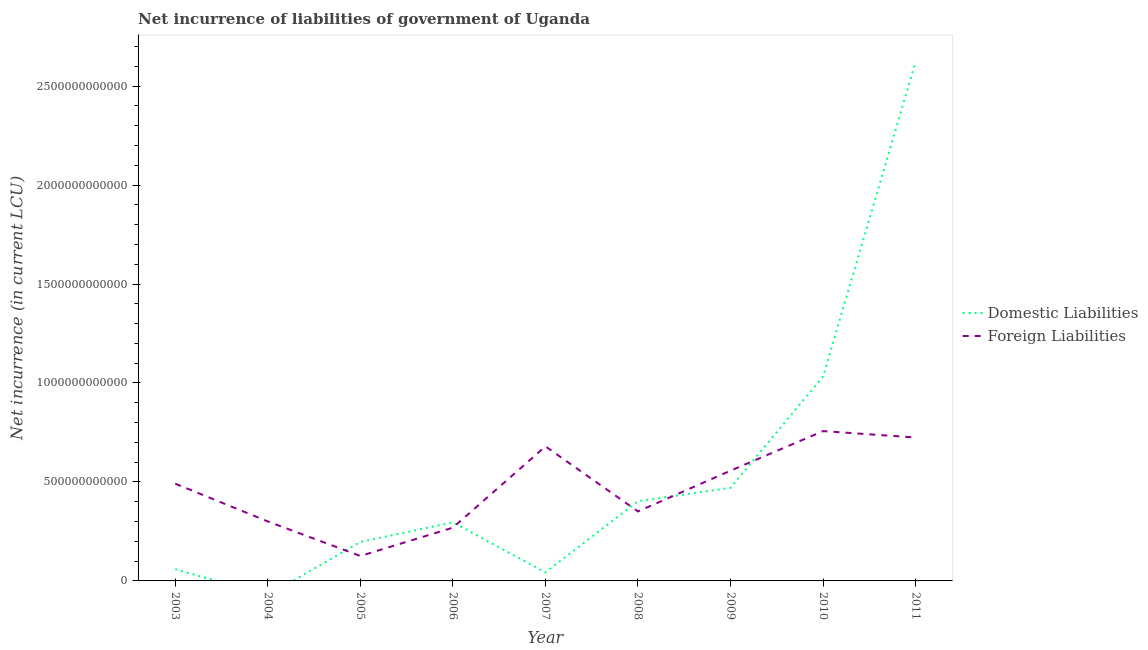What is the net incurrence of foreign liabilities in 2007?
Ensure brevity in your answer.  6.80e+11. Across all years, what is the maximum net incurrence of domestic liabilities?
Give a very brief answer. 2.62e+12. Across all years, what is the minimum net incurrence of domestic liabilities?
Keep it short and to the point. 0. In which year was the net incurrence of foreign liabilities maximum?
Provide a succinct answer. 2010. What is the total net incurrence of domestic liabilities in the graph?
Give a very brief answer. 5.13e+12. What is the difference between the net incurrence of domestic liabilities in 2003 and that in 2006?
Ensure brevity in your answer.  -2.37e+11. What is the difference between the net incurrence of domestic liabilities in 2004 and the net incurrence of foreign liabilities in 2006?
Your answer should be compact. -2.69e+11. What is the average net incurrence of foreign liabilities per year?
Your answer should be compact. 4.73e+11. In the year 2008, what is the difference between the net incurrence of domestic liabilities and net incurrence of foreign liabilities?
Your answer should be very brief. 5.17e+1. What is the ratio of the net incurrence of domestic liabilities in 2006 to that in 2007?
Your response must be concise. 6.84. Is the net incurrence of domestic liabilities in 2006 less than that in 2007?
Provide a succinct answer. No. What is the difference between the highest and the second highest net incurrence of domestic liabilities?
Provide a succinct answer. 1.59e+12. What is the difference between the highest and the lowest net incurrence of domestic liabilities?
Your answer should be very brief. 2.62e+12. In how many years, is the net incurrence of domestic liabilities greater than the average net incurrence of domestic liabilities taken over all years?
Offer a very short reply. 2. Is the sum of the net incurrence of foreign liabilities in 2008 and 2011 greater than the maximum net incurrence of domestic liabilities across all years?
Make the answer very short. No. How many lines are there?
Your answer should be very brief. 2. What is the difference between two consecutive major ticks on the Y-axis?
Give a very brief answer. 5.00e+11. Are the values on the major ticks of Y-axis written in scientific E-notation?
Ensure brevity in your answer.  No. Does the graph contain any zero values?
Offer a terse response. Yes. How are the legend labels stacked?
Keep it short and to the point. Vertical. What is the title of the graph?
Give a very brief answer. Net incurrence of liabilities of government of Uganda. What is the label or title of the X-axis?
Your answer should be compact. Year. What is the label or title of the Y-axis?
Make the answer very short. Net incurrence (in current LCU). What is the Net incurrence (in current LCU) in Domestic Liabilities in 2003?
Your answer should be very brief. 5.90e+1. What is the Net incurrence (in current LCU) of Foreign Liabilities in 2003?
Your response must be concise. 4.91e+11. What is the Net incurrence (in current LCU) of Domestic Liabilities in 2004?
Provide a short and direct response. 0. What is the Net incurrence (in current LCU) of Foreign Liabilities in 2004?
Provide a short and direct response. 3.01e+11. What is the Net incurrence (in current LCU) in Domestic Liabilities in 2005?
Ensure brevity in your answer.  1.97e+11. What is the Net incurrence (in current LCU) in Foreign Liabilities in 2005?
Provide a succinct answer. 1.26e+11. What is the Net incurrence (in current LCU) of Domestic Liabilities in 2006?
Provide a succinct answer. 2.96e+11. What is the Net incurrence (in current LCU) in Foreign Liabilities in 2006?
Offer a terse response. 2.69e+11. What is the Net incurrence (in current LCU) of Domestic Liabilities in 2007?
Make the answer very short. 4.32e+1. What is the Net incurrence (in current LCU) in Foreign Liabilities in 2007?
Keep it short and to the point. 6.80e+11. What is the Net incurrence (in current LCU) in Domestic Liabilities in 2008?
Ensure brevity in your answer.  4.03e+11. What is the Net incurrence (in current LCU) of Foreign Liabilities in 2008?
Offer a very short reply. 3.51e+11. What is the Net incurrence (in current LCU) in Domestic Liabilities in 2009?
Ensure brevity in your answer.  4.70e+11. What is the Net incurrence (in current LCU) in Foreign Liabilities in 2009?
Keep it short and to the point. 5.57e+11. What is the Net incurrence (in current LCU) in Domestic Liabilities in 2010?
Offer a terse response. 1.03e+12. What is the Net incurrence (in current LCU) of Foreign Liabilities in 2010?
Give a very brief answer. 7.57e+11. What is the Net incurrence (in current LCU) in Domestic Liabilities in 2011?
Make the answer very short. 2.62e+12. What is the Net incurrence (in current LCU) in Foreign Liabilities in 2011?
Provide a succinct answer. 7.25e+11. Across all years, what is the maximum Net incurrence (in current LCU) of Domestic Liabilities?
Give a very brief answer. 2.62e+12. Across all years, what is the maximum Net incurrence (in current LCU) in Foreign Liabilities?
Keep it short and to the point. 7.57e+11. Across all years, what is the minimum Net incurrence (in current LCU) of Foreign Liabilities?
Ensure brevity in your answer.  1.26e+11. What is the total Net incurrence (in current LCU) of Domestic Liabilities in the graph?
Make the answer very short. 5.13e+12. What is the total Net incurrence (in current LCU) of Foreign Liabilities in the graph?
Offer a very short reply. 4.26e+12. What is the difference between the Net incurrence (in current LCU) of Foreign Liabilities in 2003 and that in 2004?
Give a very brief answer. 1.91e+11. What is the difference between the Net incurrence (in current LCU) of Domestic Liabilities in 2003 and that in 2005?
Provide a succinct answer. -1.38e+11. What is the difference between the Net incurrence (in current LCU) in Foreign Liabilities in 2003 and that in 2005?
Offer a very short reply. 3.65e+11. What is the difference between the Net incurrence (in current LCU) of Domestic Liabilities in 2003 and that in 2006?
Keep it short and to the point. -2.37e+11. What is the difference between the Net incurrence (in current LCU) of Foreign Liabilities in 2003 and that in 2006?
Provide a short and direct response. 2.22e+11. What is the difference between the Net incurrence (in current LCU) of Domestic Liabilities in 2003 and that in 2007?
Provide a short and direct response. 1.58e+1. What is the difference between the Net incurrence (in current LCU) of Foreign Liabilities in 2003 and that in 2007?
Make the answer very short. -1.88e+11. What is the difference between the Net incurrence (in current LCU) of Domestic Liabilities in 2003 and that in 2008?
Offer a terse response. -3.44e+11. What is the difference between the Net incurrence (in current LCU) in Foreign Liabilities in 2003 and that in 2008?
Offer a very short reply. 1.40e+11. What is the difference between the Net incurrence (in current LCU) in Domestic Liabilities in 2003 and that in 2009?
Ensure brevity in your answer.  -4.11e+11. What is the difference between the Net incurrence (in current LCU) in Foreign Liabilities in 2003 and that in 2009?
Keep it short and to the point. -6.58e+1. What is the difference between the Net incurrence (in current LCU) in Domestic Liabilities in 2003 and that in 2010?
Keep it short and to the point. -9.74e+11. What is the difference between the Net incurrence (in current LCU) in Foreign Liabilities in 2003 and that in 2010?
Offer a very short reply. -2.66e+11. What is the difference between the Net incurrence (in current LCU) in Domestic Liabilities in 2003 and that in 2011?
Provide a succinct answer. -2.56e+12. What is the difference between the Net incurrence (in current LCU) of Foreign Liabilities in 2003 and that in 2011?
Offer a terse response. -2.33e+11. What is the difference between the Net incurrence (in current LCU) in Foreign Liabilities in 2004 and that in 2005?
Your answer should be compact. 1.75e+11. What is the difference between the Net incurrence (in current LCU) in Foreign Liabilities in 2004 and that in 2006?
Your answer should be very brief. 3.14e+1. What is the difference between the Net incurrence (in current LCU) of Foreign Liabilities in 2004 and that in 2007?
Give a very brief answer. -3.79e+11. What is the difference between the Net incurrence (in current LCU) in Foreign Liabilities in 2004 and that in 2008?
Keep it short and to the point. -5.05e+1. What is the difference between the Net incurrence (in current LCU) in Foreign Liabilities in 2004 and that in 2009?
Give a very brief answer. -2.56e+11. What is the difference between the Net incurrence (in current LCU) in Foreign Liabilities in 2004 and that in 2010?
Offer a very short reply. -4.56e+11. What is the difference between the Net incurrence (in current LCU) of Foreign Liabilities in 2004 and that in 2011?
Provide a short and direct response. -4.24e+11. What is the difference between the Net incurrence (in current LCU) of Domestic Liabilities in 2005 and that in 2006?
Your response must be concise. -9.90e+1. What is the difference between the Net incurrence (in current LCU) of Foreign Liabilities in 2005 and that in 2006?
Offer a very short reply. -1.43e+11. What is the difference between the Net incurrence (in current LCU) in Domestic Liabilities in 2005 and that in 2007?
Keep it short and to the point. 1.54e+11. What is the difference between the Net incurrence (in current LCU) of Foreign Liabilities in 2005 and that in 2007?
Provide a succinct answer. -5.54e+11. What is the difference between the Net incurrence (in current LCU) in Domestic Liabilities in 2005 and that in 2008?
Offer a terse response. -2.06e+11. What is the difference between the Net incurrence (in current LCU) in Foreign Liabilities in 2005 and that in 2008?
Ensure brevity in your answer.  -2.25e+11. What is the difference between the Net incurrence (in current LCU) in Domestic Liabilities in 2005 and that in 2009?
Your response must be concise. -2.74e+11. What is the difference between the Net incurrence (in current LCU) of Foreign Liabilities in 2005 and that in 2009?
Offer a very short reply. -4.31e+11. What is the difference between the Net incurrence (in current LCU) of Domestic Liabilities in 2005 and that in 2010?
Make the answer very short. -8.36e+11. What is the difference between the Net incurrence (in current LCU) of Foreign Liabilities in 2005 and that in 2010?
Your response must be concise. -6.31e+11. What is the difference between the Net incurrence (in current LCU) in Domestic Liabilities in 2005 and that in 2011?
Give a very brief answer. -2.43e+12. What is the difference between the Net incurrence (in current LCU) of Foreign Liabilities in 2005 and that in 2011?
Your answer should be very brief. -5.99e+11. What is the difference between the Net incurrence (in current LCU) in Domestic Liabilities in 2006 and that in 2007?
Give a very brief answer. 2.53e+11. What is the difference between the Net incurrence (in current LCU) in Foreign Liabilities in 2006 and that in 2007?
Offer a terse response. -4.11e+11. What is the difference between the Net incurrence (in current LCU) of Domestic Liabilities in 2006 and that in 2008?
Ensure brevity in your answer.  -1.07e+11. What is the difference between the Net incurrence (in current LCU) of Foreign Liabilities in 2006 and that in 2008?
Offer a terse response. -8.19e+1. What is the difference between the Net incurrence (in current LCU) of Domestic Liabilities in 2006 and that in 2009?
Offer a terse response. -1.75e+11. What is the difference between the Net incurrence (in current LCU) in Foreign Liabilities in 2006 and that in 2009?
Your answer should be compact. -2.88e+11. What is the difference between the Net incurrence (in current LCU) of Domestic Liabilities in 2006 and that in 2010?
Offer a terse response. -7.37e+11. What is the difference between the Net incurrence (in current LCU) of Foreign Liabilities in 2006 and that in 2010?
Offer a very short reply. -4.88e+11. What is the difference between the Net incurrence (in current LCU) of Domestic Liabilities in 2006 and that in 2011?
Make the answer very short. -2.33e+12. What is the difference between the Net incurrence (in current LCU) in Foreign Liabilities in 2006 and that in 2011?
Your answer should be compact. -4.55e+11. What is the difference between the Net incurrence (in current LCU) of Domestic Liabilities in 2007 and that in 2008?
Offer a very short reply. -3.60e+11. What is the difference between the Net incurrence (in current LCU) in Foreign Liabilities in 2007 and that in 2008?
Ensure brevity in your answer.  3.29e+11. What is the difference between the Net incurrence (in current LCU) in Domestic Liabilities in 2007 and that in 2009?
Your answer should be compact. -4.27e+11. What is the difference between the Net incurrence (in current LCU) in Foreign Liabilities in 2007 and that in 2009?
Offer a terse response. 1.23e+11. What is the difference between the Net incurrence (in current LCU) of Domestic Liabilities in 2007 and that in 2010?
Offer a terse response. -9.90e+11. What is the difference between the Net incurrence (in current LCU) in Foreign Liabilities in 2007 and that in 2010?
Your answer should be very brief. -7.73e+1. What is the difference between the Net incurrence (in current LCU) in Domestic Liabilities in 2007 and that in 2011?
Give a very brief answer. -2.58e+12. What is the difference between the Net incurrence (in current LCU) of Foreign Liabilities in 2007 and that in 2011?
Give a very brief answer. -4.49e+1. What is the difference between the Net incurrence (in current LCU) of Domestic Liabilities in 2008 and that in 2009?
Make the answer very short. -6.77e+1. What is the difference between the Net incurrence (in current LCU) in Foreign Liabilities in 2008 and that in 2009?
Provide a succinct answer. -2.06e+11. What is the difference between the Net incurrence (in current LCU) of Domestic Liabilities in 2008 and that in 2010?
Your answer should be very brief. -6.30e+11. What is the difference between the Net incurrence (in current LCU) of Foreign Liabilities in 2008 and that in 2010?
Make the answer very short. -4.06e+11. What is the difference between the Net incurrence (in current LCU) in Domestic Liabilities in 2008 and that in 2011?
Provide a succinct answer. -2.22e+12. What is the difference between the Net incurrence (in current LCU) in Foreign Liabilities in 2008 and that in 2011?
Give a very brief answer. -3.74e+11. What is the difference between the Net incurrence (in current LCU) in Domestic Liabilities in 2009 and that in 2010?
Provide a succinct answer. -5.63e+11. What is the difference between the Net incurrence (in current LCU) of Foreign Liabilities in 2009 and that in 2010?
Your response must be concise. -2.00e+11. What is the difference between the Net incurrence (in current LCU) of Domestic Liabilities in 2009 and that in 2011?
Make the answer very short. -2.15e+12. What is the difference between the Net incurrence (in current LCU) in Foreign Liabilities in 2009 and that in 2011?
Ensure brevity in your answer.  -1.68e+11. What is the difference between the Net incurrence (in current LCU) in Domestic Liabilities in 2010 and that in 2011?
Ensure brevity in your answer.  -1.59e+12. What is the difference between the Net incurrence (in current LCU) in Foreign Liabilities in 2010 and that in 2011?
Your answer should be very brief. 3.24e+1. What is the difference between the Net incurrence (in current LCU) of Domestic Liabilities in 2003 and the Net incurrence (in current LCU) of Foreign Liabilities in 2004?
Offer a terse response. -2.42e+11. What is the difference between the Net incurrence (in current LCU) of Domestic Liabilities in 2003 and the Net incurrence (in current LCU) of Foreign Liabilities in 2005?
Keep it short and to the point. -6.69e+1. What is the difference between the Net incurrence (in current LCU) in Domestic Liabilities in 2003 and the Net incurrence (in current LCU) in Foreign Liabilities in 2006?
Provide a short and direct response. -2.10e+11. What is the difference between the Net incurrence (in current LCU) of Domestic Liabilities in 2003 and the Net incurrence (in current LCU) of Foreign Liabilities in 2007?
Your response must be concise. -6.21e+11. What is the difference between the Net incurrence (in current LCU) in Domestic Liabilities in 2003 and the Net incurrence (in current LCU) in Foreign Liabilities in 2008?
Your answer should be compact. -2.92e+11. What is the difference between the Net incurrence (in current LCU) of Domestic Liabilities in 2003 and the Net incurrence (in current LCU) of Foreign Liabilities in 2009?
Make the answer very short. -4.98e+11. What is the difference between the Net incurrence (in current LCU) in Domestic Liabilities in 2003 and the Net incurrence (in current LCU) in Foreign Liabilities in 2010?
Offer a terse response. -6.98e+11. What is the difference between the Net incurrence (in current LCU) in Domestic Liabilities in 2003 and the Net incurrence (in current LCU) in Foreign Liabilities in 2011?
Give a very brief answer. -6.66e+11. What is the difference between the Net incurrence (in current LCU) in Domestic Liabilities in 2005 and the Net incurrence (in current LCU) in Foreign Liabilities in 2006?
Provide a short and direct response. -7.23e+1. What is the difference between the Net incurrence (in current LCU) of Domestic Liabilities in 2005 and the Net incurrence (in current LCU) of Foreign Liabilities in 2007?
Offer a very short reply. -4.83e+11. What is the difference between the Net incurrence (in current LCU) of Domestic Liabilities in 2005 and the Net incurrence (in current LCU) of Foreign Liabilities in 2008?
Provide a succinct answer. -1.54e+11. What is the difference between the Net incurrence (in current LCU) of Domestic Liabilities in 2005 and the Net incurrence (in current LCU) of Foreign Liabilities in 2009?
Your response must be concise. -3.60e+11. What is the difference between the Net incurrence (in current LCU) of Domestic Liabilities in 2005 and the Net incurrence (in current LCU) of Foreign Liabilities in 2010?
Your answer should be very brief. -5.60e+11. What is the difference between the Net incurrence (in current LCU) in Domestic Liabilities in 2005 and the Net incurrence (in current LCU) in Foreign Liabilities in 2011?
Your answer should be compact. -5.28e+11. What is the difference between the Net incurrence (in current LCU) of Domestic Liabilities in 2006 and the Net incurrence (in current LCU) of Foreign Liabilities in 2007?
Your answer should be very brief. -3.84e+11. What is the difference between the Net incurrence (in current LCU) in Domestic Liabilities in 2006 and the Net incurrence (in current LCU) in Foreign Liabilities in 2008?
Your response must be concise. -5.52e+1. What is the difference between the Net incurrence (in current LCU) in Domestic Liabilities in 2006 and the Net incurrence (in current LCU) in Foreign Liabilities in 2009?
Keep it short and to the point. -2.61e+11. What is the difference between the Net incurrence (in current LCU) of Domestic Liabilities in 2006 and the Net incurrence (in current LCU) of Foreign Liabilities in 2010?
Ensure brevity in your answer.  -4.61e+11. What is the difference between the Net incurrence (in current LCU) of Domestic Liabilities in 2006 and the Net incurrence (in current LCU) of Foreign Liabilities in 2011?
Ensure brevity in your answer.  -4.29e+11. What is the difference between the Net incurrence (in current LCU) in Domestic Liabilities in 2007 and the Net incurrence (in current LCU) in Foreign Liabilities in 2008?
Provide a succinct answer. -3.08e+11. What is the difference between the Net incurrence (in current LCU) of Domestic Liabilities in 2007 and the Net incurrence (in current LCU) of Foreign Liabilities in 2009?
Provide a short and direct response. -5.14e+11. What is the difference between the Net incurrence (in current LCU) in Domestic Liabilities in 2007 and the Net incurrence (in current LCU) in Foreign Liabilities in 2010?
Give a very brief answer. -7.14e+11. What is the difference between the Net incurrence (in current LCU) of Domestic Liabilities in 2007 and the Net incurrence (in current LCU) of Foreign Liabilities in 2011?
Offer a terse response. -6.81e+11. What is the difference between the Net incurrence (in current LCU) of Domestic Liabilities in 2008 and the Net incurrence (in current LCU) of Foreign Liabilities in 2009?
Give a very brief answer. -1.54e+11. What is the difference between the Net incurrence (in current LCU) in Domestic Liabilities in 2008 and the Net incurrence (in current LCU) in Foreign Liabilities in 2010?
Give a very brief answer. -3.54e+11. What is the difference between the Net incurrence (in current LCU) of Domestic Liabilities in 2008 and the Net incurrence (in current LCU) of Foreign Liabilities in 2011?
Your answer should be compact. -3.22e+11. What is the difference between the Net incurrence (in current LCU) in Domestic Liabilities in 2009 and the Net incurrence (in current LCU) in Foreign Liabilities in 2010?
Your answer should be compact. -2.86e+11. What is the difference between the Net incurrence (in current LCU) in Domestic Liabilities in 2009 and the Net incurrence (in current LCU) in Foreign Liabilities in 2011?
Your answer should be compact. -2.54e+11. What is the difference between the Net incurrence (in current LCU) of Domestic Liabilities in 2010 and the Net incurrence (in current LCU) of Foreign Liabilities in 2011?
Your answer should be compact. 3.09e+11. What is the average Net incurrence (in current LCU) in Domestic Liabilities per year?
Your response must be concise. 5.69e+11. What is the average Net incurrence (in current LCU) of Foreign Liabilities per year?
Your response must be concise. 4.73e+11. In the year 2003, what is the difference between the Net incurrence (in current LCU) in Domestic Liabilities and Net incurrence (in current LCU) in Foreign Liabilities?
Make the answer very short. -4.32e+11. In the year 2005, what is the difference between the Net incurrence (in current LCU) in Domestic Liabilities and Net incurrence (in current LCU) in Foreign Liabilities?
Give a very brief answer. 7.09e+1. In the year 2006, what is the difference between the Net incurrence (in current LCU) in Domestic Liabilities and Net incurrence (in current LCU) in Foreign Liabilities?
Your answer should be compact. 2.67e+1. In the year 2007, what is the difference between the Net incurrence (in current LCU) of Domestic Liabilities and Net incurrence (in current LCU) of Foreign Liabilities?
Ensure brevity in your answer.  -6.36e+11. In the year 2008, what is the difference between the Net incurrence (in current LCU) in Domestic Liabilities and Net incurrence (in current LCU) in Foreign Liabilities?
Give a very brief answer. 5.17e+1. In the year 2009, what is the difference between the Net incurrence (in current LCU) in Domestic Liabilities and Net incurrence (in current LCU) in Foreign Liabilities?
Your response must be concise. -8.66e+1. In the year 2010, what is the difference between the Net incurrence (in current LCU) of Domestic Liabilities and Net incurrence (in current LCU) of Foreign Liabilities?
Provide a short and direct response. 2.76e+11. In the year 2011, what is the difference between the Net incurrence (in current LCU) of Domestic Liabilities and Net incurrence (in current LCU) of Foreign Liabilities?
Offer a terse response. 1.90e+12. What is the ratio of the Net incurrence (in current LCU) of Foreign Liabilities in 2003 to that in 2004?
Make the answer very short. 1.63. What is the ratio of the Net incurrence (in current LCU) of Domestic Liabilities in 2003 to that in 2005?
Offer a very short reply. 0.3. What is the ratio of the Net incurrence (in current LCU) of Foreign Liabilities in 2003 to that in 2005?
Keep it short and to the point. 3.9. What is the ratio of the Net incurrence (in current LCU) of Domestic Liabilities in 2003 to that in 2006?
Your response must be concise. 0.2. What is the ratio of the Net incurrence (in current LCU) in Foreign Liabilities in 2003 to that in 2006?
Offer a terse response. 1.82. What is the ratio of the Net incurrence (in current LCU) in Domestic Liabilities in 2003 to that in 2007?
Make the answer very short. 1.37. What is the ratio of the Net incurrence (in current LCU) in Foreign Liabilities in 2003 to that in 2007?
Give a very brief answer. 0.72. What is the ratio of the Net incurrence (in current LCU) of Domestic Liabilities in 2003 to that in 2008?
Make the answer very short. 0.15. What is the ratio of the Net incurrence (in current LCU) in Foreign Liabilities in 2003 to that in 2008?
Give a very brief answer. 1.4. What is the ratio of the Net incurrence (in current LCU) in Domestic Liabilities in 2003 to that in 2009?
Give a very brief answer. 0.13. What is the ratio of the Net incurrence (in current LCU) of Foreign Liabilities in 2003 to that in 2009?
Offer a terse response. 0.88. What is the ratio of the Net incurrence (in current LCU) in Domestic Liabilities in 2003 to that in 2010?
Your answer should be very brief. 0.06. What is the ratio of the Net incurrence (in current LCU) in Foreign Liabilities in 2003 to that in 2010?
Offer a very short reply. 0.65. What is the ratio of the Net incurrence (in current LCU) in Domestic Liabilities in 2003 to that in 2011?
Ensure brevity in your answer.  0.02. What is the ratio of the Net incurrence (in current LCU) of Foreign Liabilities in 2003 to that in 2011?
Give a very brief answer. 0.68. What is the ratio of the Net incurrence (in current LCU) of Foreign Liabilities in 2004 to that in 2005?
Your answer should be compact. 2.39. What is the ratio of the Net incurrence (in current LCU) of Foreign Liabilities in 2004 to that in 2006?
Give a very brief answer. 1.12. What is the ratio of the Net incurrence (in current LCU) of Foreign Liabilities in 2004 to that in 2007?
Provide a short and direct response. 0.44. What is the ratio of the Net incurrence (in current LCU) of Foreign Liabilities in 2004 to that in 2008?
Offer a very short reply. 0.86. What is the ratio of the Net incurrence (in current LCU) of Foreign Liabilities in 2004 to that in 2009?
Your response must be concise. 0.54. What is the ratio of the Net incurrence (in current LCU) in Foreign Liabilities in 2004 to that in 2010?
Provide a succinct answer. 0.4. What is the ratio of the Net incurrence (in current LCU) in Foreign Liabilities in 2004 to that in 2011?
Provide a short and direct response. 0.41. What is the ratio of the Net incurrence (in current LCU) in Domestic Liabilities in 2005 to that in 2006?
Give a very brief answer. 0.67. What is the ratio of the Net incurrence (in current LCU) in Foreign Liabilities in 2005 to that in 2006?
Make the answer very short. 0.47. What is the ratio of the Net incurrence (in current LCU) of Domestic Liabilities in 2005 to that in 2007?
Your answer should be very brief. 4.55. What is the ratio of the Net incurrence (in current LCU) in Foreign Liabilities in 2005 to that in 2007?
Provide a succinct answer. 0.19. What is the ratio of the Net incurrence (in current LCU) of Domestic Liabilities in 2005 to that in 2008?
Offer a terse response. 0.49. What is the ratio of the Net incurrence (in current LCU) of Foreign Liabilities in 2005 to that in 2008?
Your response must be concise. 0.36. What is the ratio of the Net incurrence (in current LCU) of Domestic Liabilities in 2005 to that in 2009?
Make the answer very short. 0.42. What is the ratio of the Net incurrence (in current LCU) of Foreign Liabilities in 2005 to that in 2009?
Provide a succinct answer. 0.23. What is the ratio of the Net incurrence (in current LCU) in Domestic Liabilities in 2005 to that in 2010?
Keep it short and to the point. 0.19. What is the ratio of the Net incurrence (in current LCU) in Foreign Liabilities in 2005 to that in 2010?
Your answer should be compact. 0.17. What is the ratio of the Net incurrence (in current LCU) in Domestic Liabilities in 2005 to that in 2011?
Your answer should be compact. 0.07. What is the ratio of the Net incurrence (in current LCU) in Foreign Liabilities in 2005 to that in 2011?
Your response must be concise. 0.17. What is the ratio of the Net incurrence (in current LCU) in Domestic Liabilities in 2006 to that in 2007?
Offer a terse response. 6.84. What is the ratio of the Net incurrence (in current LCU) in Foreign Liabilities in 2006 to that in 2007?
Provide a short and direct response. 0.4. What is the ratio of the Net incurrence (in current LCU) of Domestic Liabilities in 2006 to that in 2008?
Offer a terse response. 0.73. What is the ratio of the Net incurrence (in current LCU) of Foreign Liabilities in 2006 to that in 2008?
Your answer should be compact. 0.77. What is the ratio of the Net incurrence (in current LCU) of Domestic Liabilities in 2006 to that in 2009?
Your response must be concise. 0.63. What is the ratio of the Net incurrence (in current LCU) in Foreign Liabilities in 2006 to that in 2009?
Your answer should be compact. 0.48. What is the ratio of the Net incurrence (in current LCU) of Domestic Liabilities in 2006 to that in 2010?
Your answer should be compact. 0.29. What is the ratio of the Net incurrence (in current LCU) in Foreign Liabilities in 2006 to that in 2010?
Provide a succinct answer. 0.36. What is the ratio of the Net incurrence (in current LCU) of Domestic Liabilities in 2006 to that in 2011?
Your response must be concise. 0.11. What is the ratio of the Net incurrence (in current LCU) in Foreign Liabilities in 2006 to that in 2011?
Your response must be concise. 0.37. What is the ratio of the Net incurrence (in current LCU) in Domestic Liabilities in 2007 to that in 2008?
Provide a short and direct response. 0.11. What is the ratio of the Net incurrence (in current LCU) of Foreign Liabilities in 2007 to that in 2008?
Ensure brevity in your answer.  1.94. What is the ratio of the Net incurrence (in current LCU) in Domestic Liabilities in 2007 to that in 2009?
Ensure brevity in your answer.  0.09. What is the ratio of the Net incurrence (in current LCU) in Foreign Liabilities in 2007 to that in 2009?
Ensure brevity in your answer.  1.22. What is the ratio of the Net incurrence (in current LCU) of Domestic Liabilities in 2007 to that in 2010?
Ensure brevity in your answer.  0.04. What is the ratio of the Net incurrence (in current LCU) of Foreign Liabilities in 2007 to that in 2010?
Your answer should be very brief. 0.9. What is the ratio of the Net incurrence (in current LCU) of Domestic Liabilities in 2007 to that in 2011?
Provide a short and direct response. 0.02. What is the ratio of the Net incurrence (in current LCU) of Foreign Liabilities in 2007 to that in 2011?
Provide a short and direct response. 0.94. What is the ratio of the Net incurrence (in current LCU) of Domestic Liabilities in 2008 to that in 2009?
Make the answer very short. 0.86. What is the ratio of the Net incurrence (in current LCU) of Foreign Liabilities in 2008 to that in 2009?
Offer a terse response. 0.63. What is the ratio of the Net incurrence (in current LCU) in Domestic Liabilities in 2008 to that in 2010?
Make the answer very short. 0.39. What is the ratio of the Net incurrence (in current LCU) of Foreign Liabilities in 2008 to that in 2010?
Give a very brief answer. 0.46. What is the ratio of the Net incurrence (in current LCU) of Domestic Liabilities in 2008 to that in 2011?
Your response must be concise. 0.15. What is the ratio of the Net incurrence (in current LCU) in Foreign Liabilities in 2008 to that in 2011?
Give a very brief answer. 0.48. What is the ratio of the Net incurrence (in current LCU) in Domestic Liabilities in 2009 to that in 2010?
Give a very brief answer. 0.46. What is the ratio of the Net incurrence (in current LCU) of Foreign Liabilities in 2009 to that in 2010?
Offer a very short reply. 0.74. What is the ratio of the Net incurrence (in current LCU) of Domestic Liabilities in 2009 to that in 2011?
Provide a short and direct response. 0.18. What is the ratio of the Net incurrence (in current LCU) in Foreign Liabilities in 2009 to that in 2011?
Your response must be concise. 0.77. What is the ratio of the Net incurrence (in current LCU) of Domestic Liabilities in 2010 to that in 2011?
Provide a succinct answer. 0.39. What is the ratio of the Net incurrence (in current LCU) in Foreign Liabilities in 2010 to that in 2011?
Your answer should be compact. 1.04. What is the difference between the highest and the second highest Net incurrence (in current LCU) in Domestic Liabilities?
Ensure brevity in your answer.  1.59e+12. What is the difference between the highest and the second highest Net incurrence (in current LCU) in Foreign Liabilities?
Your answer should be very brief. 3.24e+1. What is the difference between the highest and the lowest Net incurrence (in current LCU) of Domestic Liabilities?
Your response must be concise. 2.62e+12. What is the difference between the highest and the lowest Net incurrence (in current LCU) of Foreign Liabilities?
Make the answer very short. 6.31e+11. 